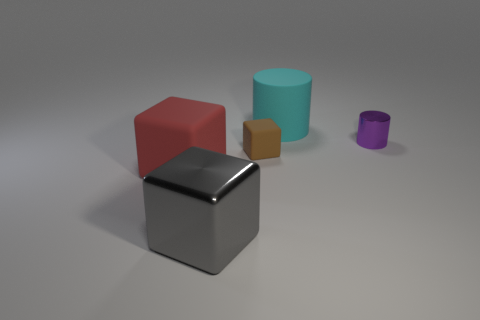Add 3 purple shiny cylinders. How many objects exist? 8 Subtract all cylinders. How many objects are left? 3 Subtract all brown blocks. Subtract all large cubes. How many objects are left? 2 Add 1 large cyan cylinders. How many large cyan cylinders are left? 2 Add 4 large gray cylinders. How many large gray cylinders exist? 4 Subtract 0 brown balls. How many objects are left? 5 